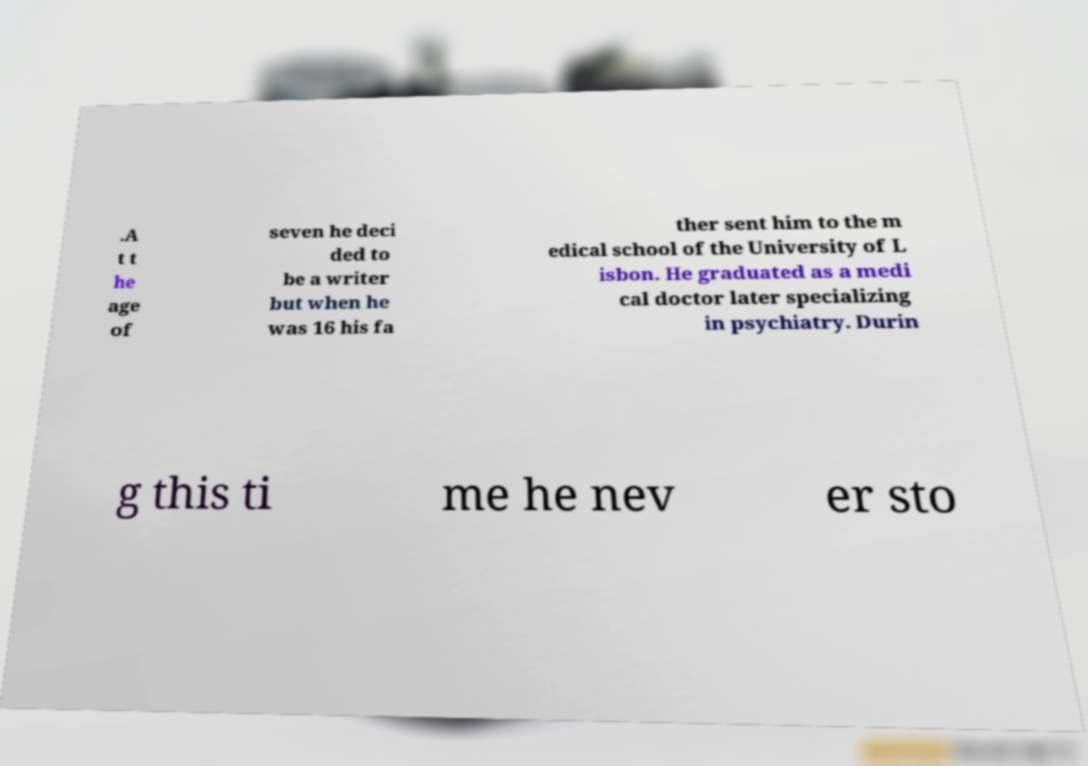Could you assist in decoding the text presented in this image and type it out clearly? .A t t he age of seven he deci ded to be a writer but when he was 16 his fa ther sent him to the m edical school of the University of L isbon. He graduated as a medi cal doctor later specializing in psychiatry. Durin g this ti me he nev er sto 